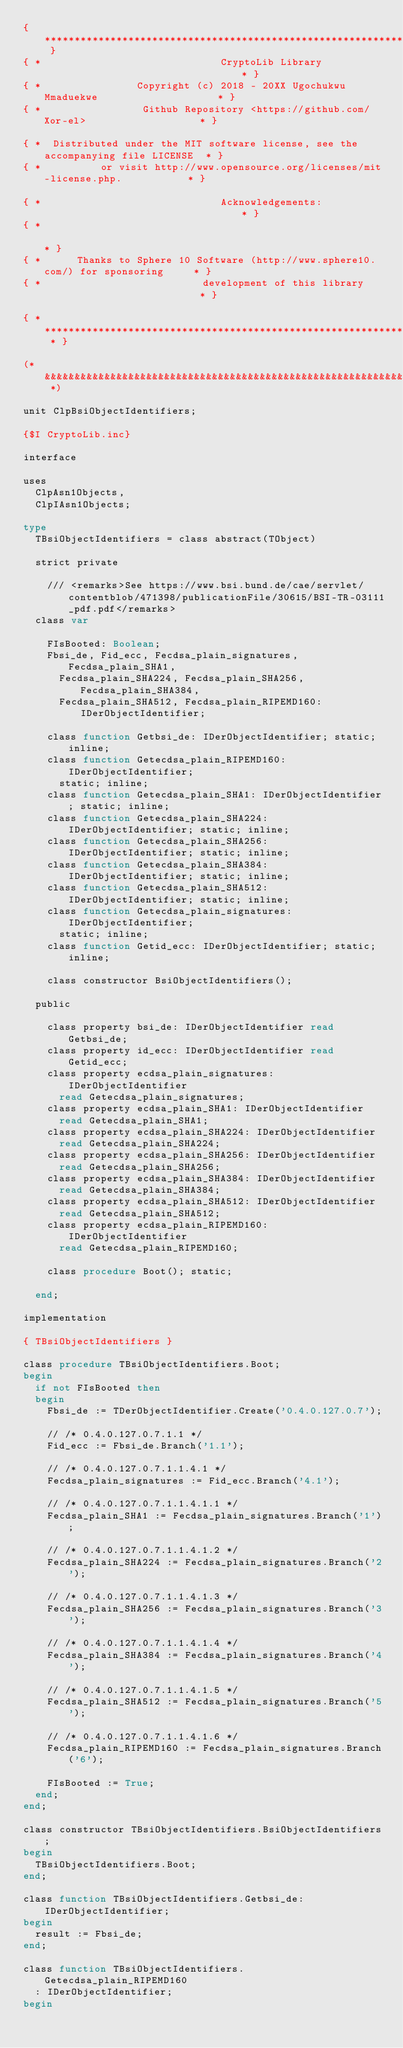<code> <loc_0><loc_0><loc_500><loc_500><_Pascal_>{ *********************************************************************************** }
{ *                              CryptoLib Library                                  * }
{ *                Copyright (c) 2018 - 20XX Ugochukwu Mmaduekwe                    * }
{ *                 Github Repository <https://github.com/Xor-el>                   * }

{ *  Distributed under the MIT software license, see the accompanying file LICENSE  * }
{ *          or visit http://www.opensource.org/licenses/mit-license.php.           * }

{ *                              Acknowledgements:                                  * }
{ *                                                                                 * }
{ *      Thanks to Sphere 10 Software (http://www.sphere10.com/) for sponsoring     * }
{ *                           development of this library                           * }

{ * ******************************************************************************* * }

(* &&&&&&&&&&&&&&&&&&&&&&&&&&&&&&&&&&&&&&&&&&&&&&&&&&&&&&&&&&&&&&&&&&&&&&&&&&&&&&&&& *)

unit ClpBsiObjectIdentifiers;

{$I CryptoLib.inc}

interface

uses
  ClpAsn1Objects,
  ClpIAsn1Objects;

type
  TBsiObjectIdentifiers = class abstract(TObject)

  strict private

    /// <remarks>See https://www.bsi.bund.de/cae/servlet/contentblob/471398/publicationFile/30615/BSI-TR-03111_pdf.pdf</remarks>
  class var

    FIsBooted: Boolean;
    Fbsi_de, Fid_ecc, Fecdsa_plain_signatures, Fecdsa_plain_SHA1,
      Fecdsa_plain_SHA224, Fecdsa_plain_SHA256, Fecdsa_plain_SHA384,
      Fecdsa_plain_SHA512, Fecdsa_plain_RIPEMD160: IDerObjectIdentifier;

    class function Getbsi_de: IDerObjectIdentifier; static; inline;
    class function Getecdsa_plain_RIPEMD160: IDerObjectIdentifier;
      static; inline;
    class function Getecdsa_plain_SHA1: IDerObjectIdentifier; static; inline;
    class function Getecdsa_plain_SHA224: IDerObjectIdentifier; static; inline;
    class function Getecdsa_plain_SHA256: IDerObjectIdentifier; static; inline;
    class function Getecdsa_plain_SHA384: IDerObjectIdentifier; static; inline;
    class function Getecdsa_plain_SHA512: IDerObjectIdentifier; static; inline;
    class function Getecdsa_plain_signatures: IDerObjectIdentifier;
      static; inline;
    class function Getid_ecc: IDerObjectIdentifier; static; inline;

    class constructor BsiObjectIdentifiers();

  public

    class property bsi_de: IDerObjectIdentifier read Getbsi_de;
    class property id_ecc: IDerObjectIdentifier read Getid_ecc;
    class property ecdsa_plain_signatures: IDerObjectIdentifier
      read Getecdsa_plain_signatures;
    class property ecdsa_plain_SHA1: IDerObjectIdentifier
      read Getecdsa_plain_SHA1;
    class property ecdsa_plain_SHA224: IDerObjectIdentifier
      read Getecdsa_plain_SHA224;
    class property ecdsa_plain_SHA256: IDerObjectIdentifier
      read Getecdsa_plain_SHA256;
    class property ecdsa_plain_SHA384: IDerObjectIdentifier
      read Getecdsa_plain_SHA384;
    class property ecdsa_plain_SHA512: IDerObjectIdentifier
      read Getecdsa_plain_SHA512;
    class property ecdsa_plain_RIPEMD160: IDerObjectIdentifier
      read Getecdsa_plain_RIPEMD160;

    class procedure Boot(); static;

  end;

implementation

{ TBsiObjectIdentifiers }

class procedure TBsiObjectIdentifiers.Boot;
begin
  if not FIsBooted then
  begin
    Fbsi_de := TDerObjectIdentifier.Create('0.4.0.127.0.7');

    // /* 0.4.0.127.0.7.1.1 */
    Fid_ecc := Fbsi_de.Branch('1.1');

    // /* 0.4.0.127.0.7.1.1.4.1 */
    Fecdsa_plain_signatures := Fid_ecc.Branch('4.1');

    // /* 0.4.0.127.0.7.1.1.4.1.1 */
    Fecdsa_plain_SHA1 := Fecdsa_plain_signatures.Branch('1');

    // /* 0.4.0.127.0.7.1.1.4.1.2 */
    Fecdsa_plain_SHA224 := Fecdsa_plain_signatures.Branch('2');

    // /* 0.4.0.127.0.7.1.1.4.1.3 */
    Fecdsa_plain_SHA256 := Fecdsa_plain_signatures.Branch('3');

    // /* 0.4.0.127.0.7.1.1.4.1.4 */
    Fecdsa_plain_SHA384 := Fecdsa_plain_signatures.Branch('4');

    // /* 0.4.0.127.0.7.1.1.4.1.5 */
    Fecdsa_plain_SHA512 := Fecdsa_plain_signatures.Branch('5');

    // /* 0.4.0.127.0.7.1.1.4.1.6 */
    Fecdsa_plain_RIPEMD160 := Fecdsa_plain_signatures.Branch('6');

    FIsBooted := True;
  end;
end;

class constructor TBsiObjectIdentifiers.BsiObjectIdentifiers;
begin
  TBsiObjectIdentifiers.Boot;
end;

class function TBsiObjectIdentifiers.Getbsi_de: IDerObjectIdentifier;
begin
  result := Fbsi_de;
end;

class function TBsiObjectIdentifiers.Getecdsa_plain_RIPEMD160
  : IDerObjectIdentifier;
begin</code> 